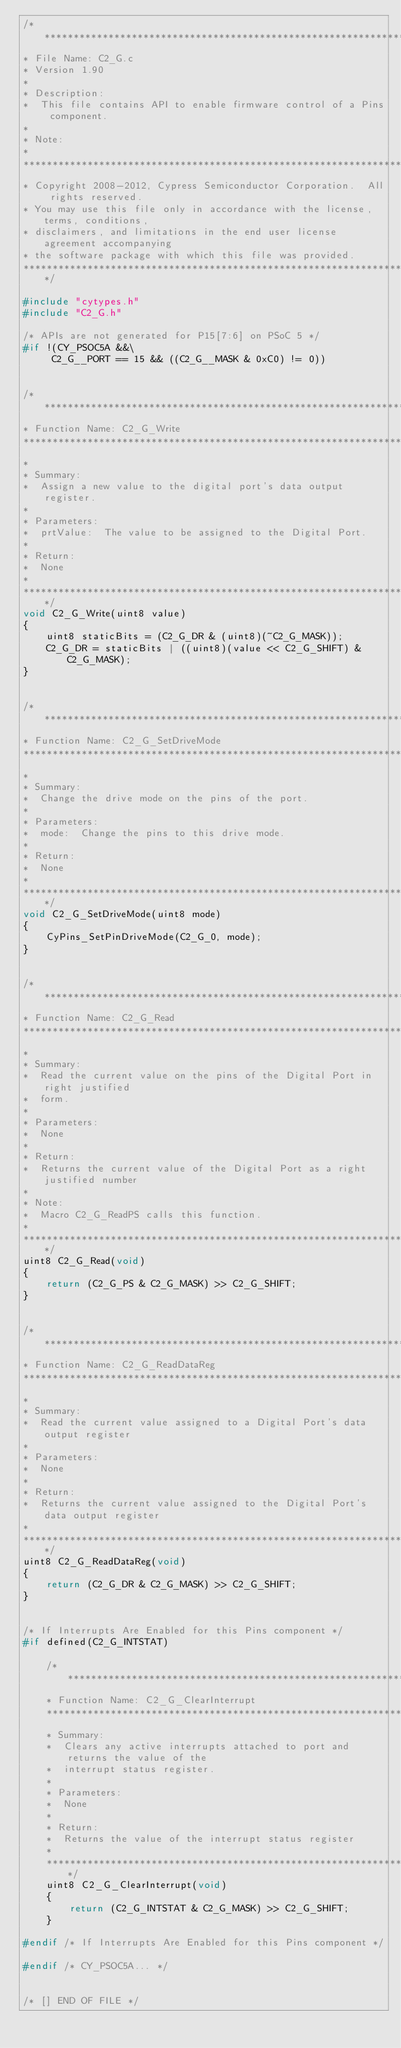<code> <loc_0><loc_0><loc_500><loc_500><_C_>/*******************************************************************************
* File Name: C2_G.c  
* Version 1.90
*
* Description:
*  This file contains API to enable firmware control of a Pins component.
*
* Note:
*
********************************************************************************
* Copyright 2008-2012, Cypress Semiconductor Corporation.  All rights reserved.
* You may use this file only in accordance with the license, terms, conditions, 
* disclaimers, and limitations in the end user license agreement accompanying 
* the software package with which this file was provided.
*******************************************************************************/

#include "cytypes.h"
#include "C2_G.h"

/* APIs are not generated for P15[7:6] on PSoC 5 */
#if !(CY_PSOC5A &&\
	 C2_G__PORT == 15 && ((C2_G__MASK & 0xC0) != 0))


/*******************************************************************************
* Function Name: C2_G_Write
********************************************************************************
*
* Summary:
*  Assign a new value to the digital port's data output register.  
*
* Parameters:  
*  prtValue:  The value to be assigned to the Digital Port. 
*
* Return: 
*  None
*  
*******************************************************************************/
void C2_G_Write(uint8 value) 
{
    uint8 staticBits = (C2_G_DR & (uint8)(~C2_G_MASK));
    C2_G_DR = staticBits | ((uint8)(value << C2_G_SHIFT) & C2_G_MASK);
}


/*******************************************************************************
* Function Name: C2_G_SetDriveMode
********************************************************************************
*
* Summary:
*  Change the drive mode on the pins of the port.
* 
* Parameters:  
*  mode:  Change the pins to this drive mode.
*
* Return: 
*  None
*
*******************************************************************************/
void C2_G_SetDriveMode(uint8 mode) 
{
	CyPins_SetPinDriveMode(C2_G_0, mode);
}


/*******************************************************************************
* Function Name: C2_G_Read
********************************************************************************
*
* Summary:
*  Read the current value on the pins of the Digital Port in right justified 
*  form.
*
* Parameters:  
*  None
*
* Return: 
*  Returns the current value of the Digital Port as a right justified number
*  
* Note:
*  Macro C2_G_ReadPS calls this function. 
*  
*******************************************************************************/
uint8 C2_G_Read(void) 
{
    return (C2_G_PS & C2_G_MASK) >> C2_G_SHIFT;
}


/*******************************************************************************
* Function Name: C2_G_ReadDataReg
********************************************************************************
*
* Summary:
*  Read the current value assigned to a Digital Port's data output register
*
* Parameters:  
*  None 
*
* Return: 
*  Returns the current value assigned to the Digital Port's data output register
*  
*******************************************************************************/
uint8 C2_G_ReadDataReg(void) 
{
    return (C2_G_DR & C2_G_MASK) >> C2_G_SHIFT;
}


/* If Interrupts Are Enabled for this Pins component */ 
#if defined(C2_G_INTSTAT) 

    /*******************************************************************************
    * Function Name: C2_G_ClearInterrupt
    ********************************************************************************
    * Summary:
    *  Clears any active interrupts attached to port and returns the value of the 
    *  interrupt status register.
    *
    * Parameters:  
    *  None 
    *
    * Return: 
    *  Returns the value of the interrupt status register
    *  
    *******************************************************************************/
    uint8 C2_G_ClearInterrupt(void) 
    {
        return (C2_G_INTSTAT & C2_G_MASK) >> C2_G_SHIFT;
    }

#endif /* If Interrupts Are Enabled for this Pins component */ 

#endif /* CY_PSOC5A... */

    
/* [] END OF FILE */
</code> 